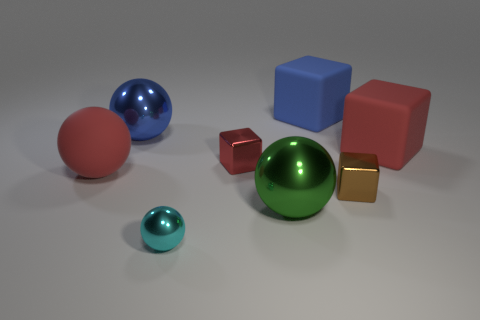There is a large block that is the same color as the large rubber ball; what is it made of?
Your answer should be compact. Rubber. The small sphere has what color?
Provide a succinct answer. Cyan. Do the red ball and the tiny block that is on the left side of the large green sphere have the same material?
Offer a terse response. No. What number of tiny metallic things are both to the left of the tiny brown block and behind the cyan metal thing?
Provide a succinct answer. 1. What is the shape of the blue shiny thing that is the same size as the rubber sphere?
Make the answer very short. Sphere. There is a large green sphere to the right of the red thing on the left side of the blue metallic object; is there a big ball that is left of it?
Your answer should be very brief. Yes. Is the color of the small sphere the same as the shiny sphere that is behind the red matte sphere?
Make the answer very short. No. What number of big things have the same color as the big rubber ball?
Make the answer very short. 1. There is a matte object that is behind the big red matte thing to the right of the matte ball; how big is it?
Keep it short and to the point. Large. What number of things are either blocks that are on the right side of the blue rubber block or large matte cylinders?
Offer a terse response. 2. 